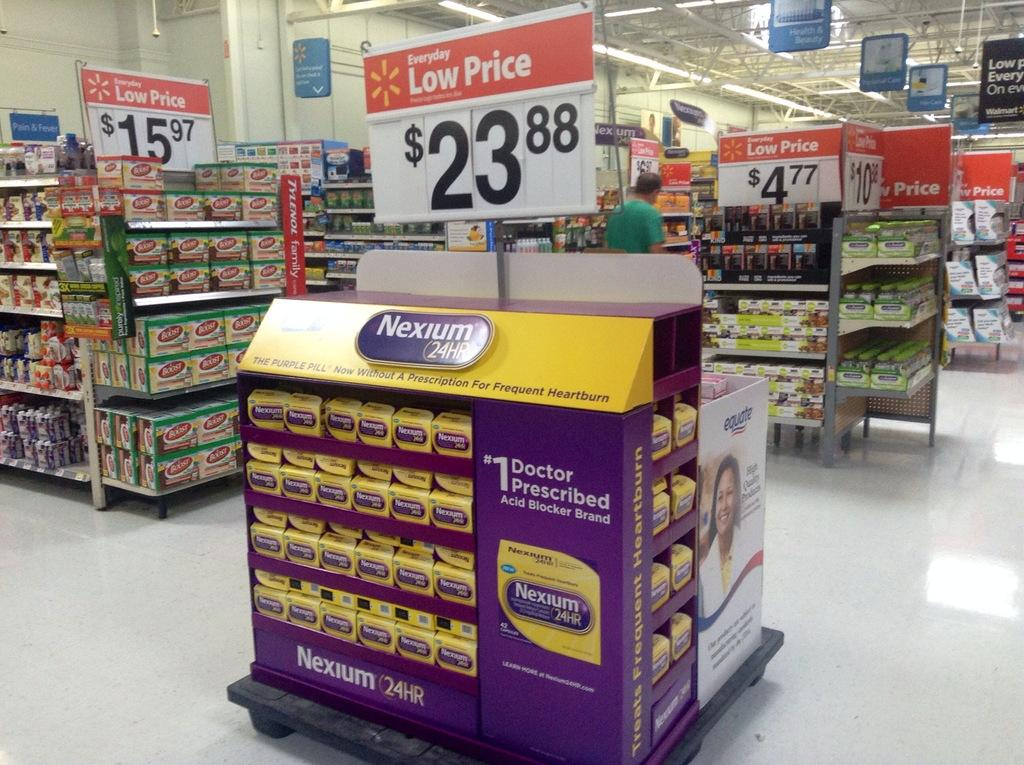Provide a one-sentence caption for the provided image. A center aisle store display of Nexium is being advertised for under $24.00. 